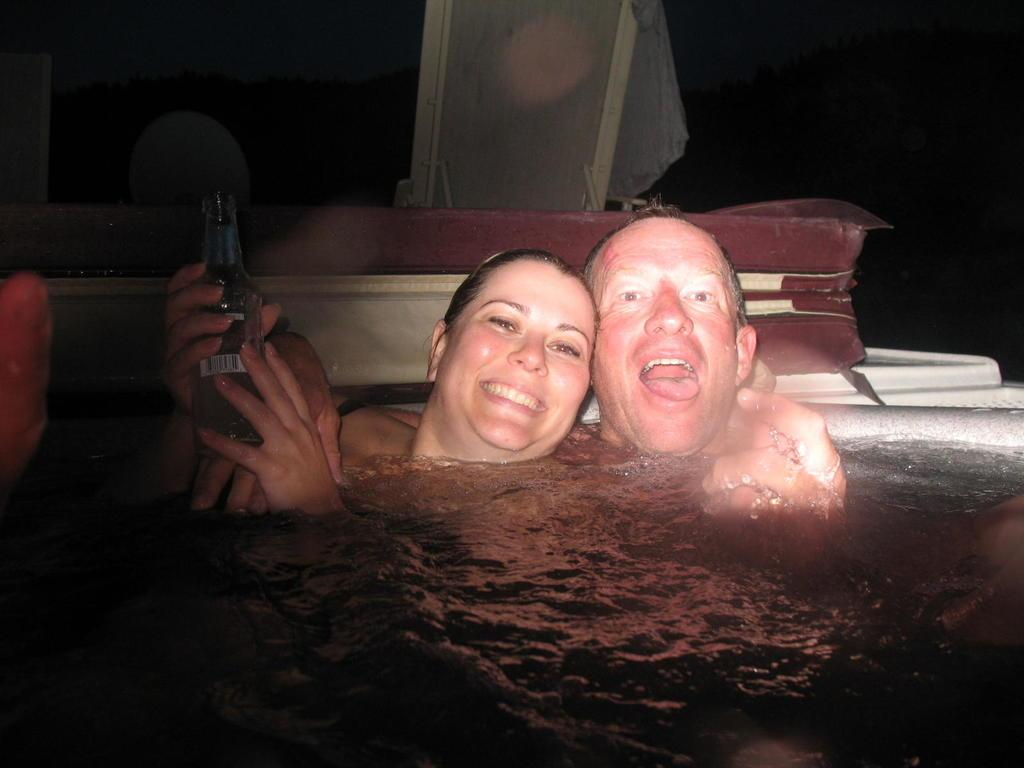What is happening in the image? There are men and women in a pool. Can you describe any specific actions or objects in the image? One woman is holding a beer bottle in her hand. What type of string is being used to hold up the jeans in the image? There are no jeans or string present in the image; it features people in a pool. How does the woman in the image show respect to her peers? The image does not provide information about the woman's actions or intentions, so it cannot be determined how she shows respect to her peers. 